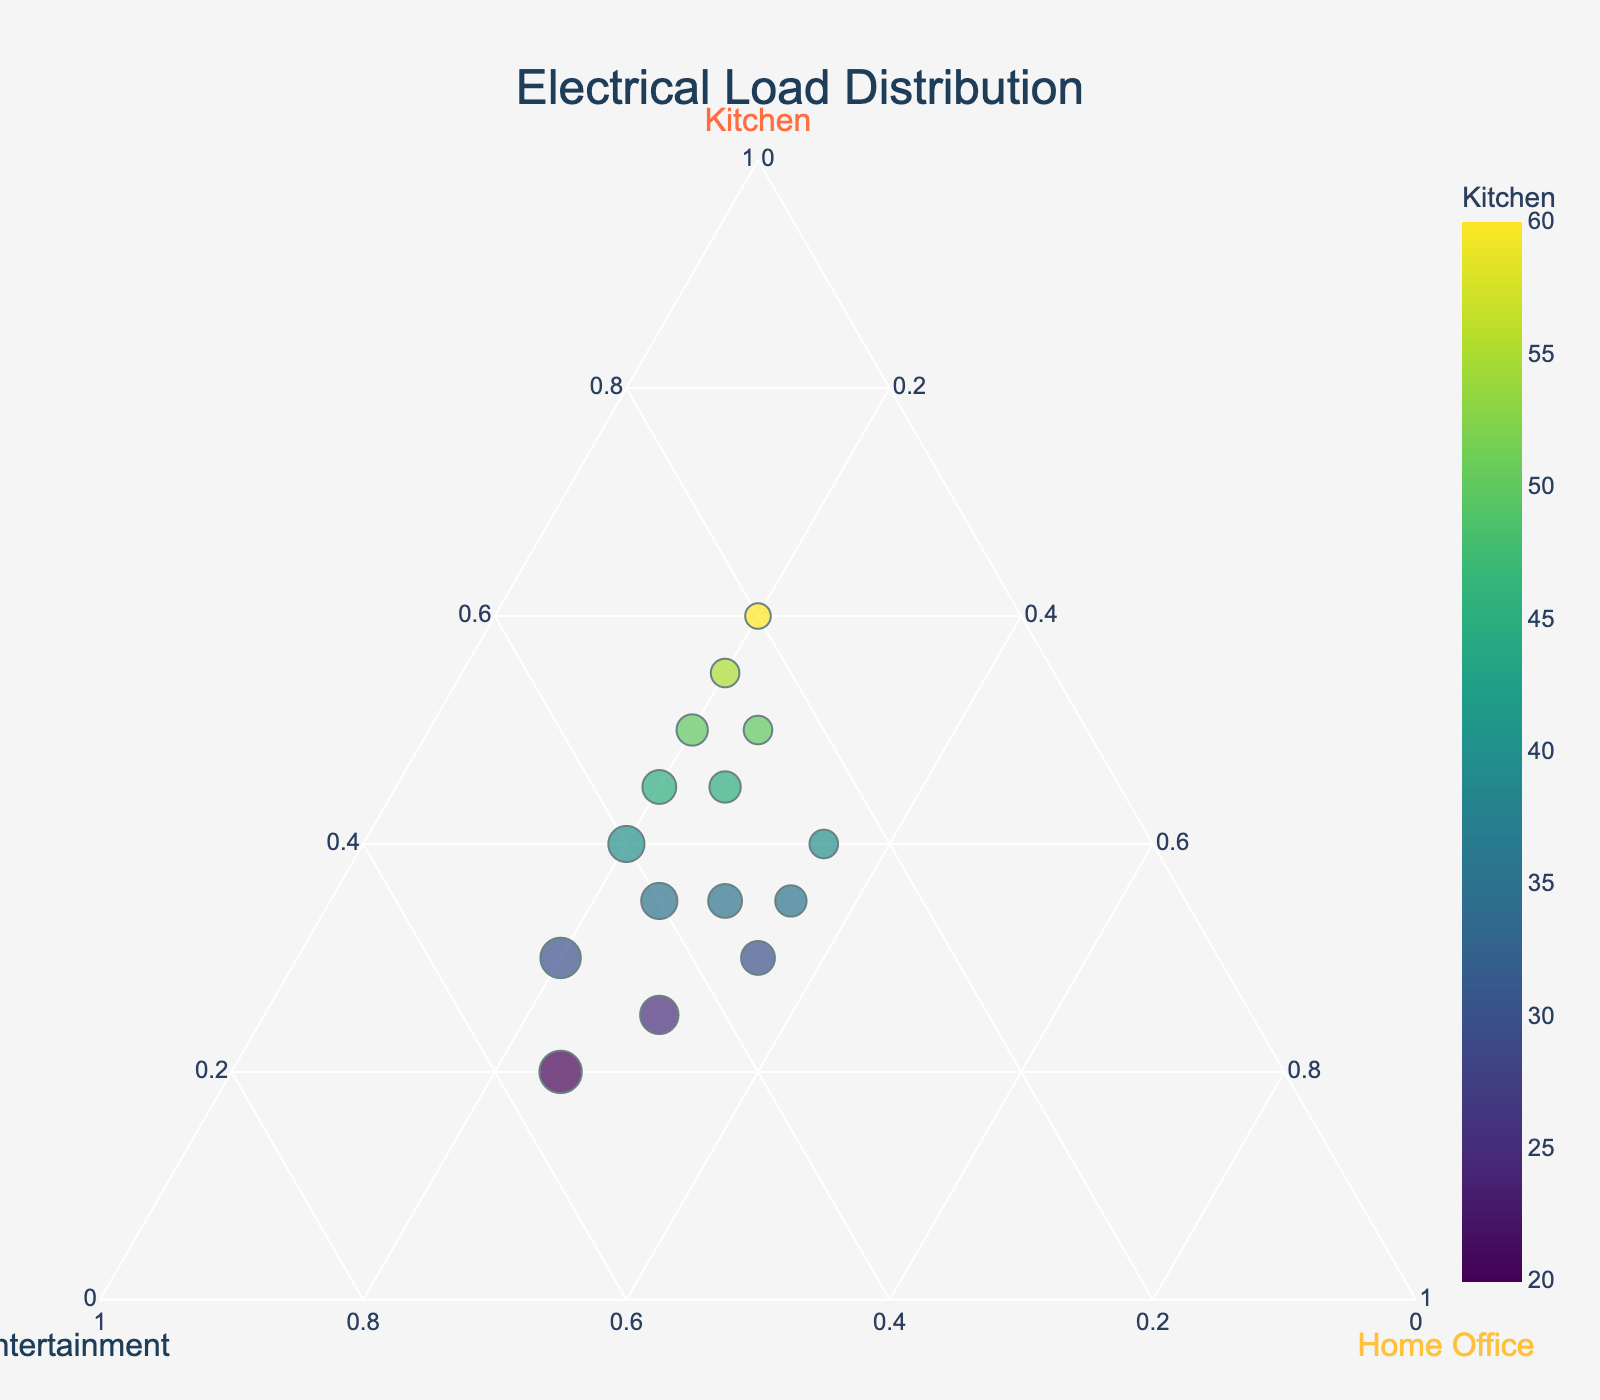How many data points are there in the figure? We can count the individual data points represented by markers on the ternary plot. Each marker indicates a separate data point.
Answer: 15 What is the title of the plot? By looking at the top of the plot, we can read the title text displayed there.
Answer: Electrical Load Distribution Which axis represents the electrical load for the Kitchen? We can identify the Kitchen axis by looking at the labels for each of the three axes on the ternary plot.
Answer: The left axis, labeled Kitchen Which data point has the highest load in the Kitchen category? We look for the point closest to the Kitchen apex on the ternary plot. This point will have the highest Kitchen load.
Answer: The data point with 60% Kitchen load Which data point has the largest marker size? Marker size is proportional to the Entertainment load. We look for the marker with the largest size to find the highest Entertainment load.
Answer: The data point with 55% Entertainment load Which category has the most varied distribution? By visually inspecting the spread of the datapoints along each axis, we identify which axis/element shows the widest range of data values.
Answer: Entertainment What is the average load percentage for the Kitchen category across all data points? Sum all Kitchen load percentages and then divide by the number of data points. (45+30+40+35+50+25+55+30+40+35+45+20+60+35+50)/15 = 595/15 ≈ 39.67
Answer: 39.67% Is there any data point where the load distribution is equal among all three categories? Visually check if any data point is located at the center of the ternary plot. The center represents equal distribution.
Answer: No How does the color gradient relate to the Kitchen load? By observing the color of the markers, we see that the color gradient indicates Kitchen load, with varying colors representing different loads.
Answer: It indicates the percentage load, with varying shades for different loads Which data point has the closest equal load between Kitchen and Home Office? Identify the marker closest to a line equidistant from the Kitchen and Home Office axes, indicating nearly equal distribution.
Answer: The data point with 35% Kitchen, 35% Home Office 